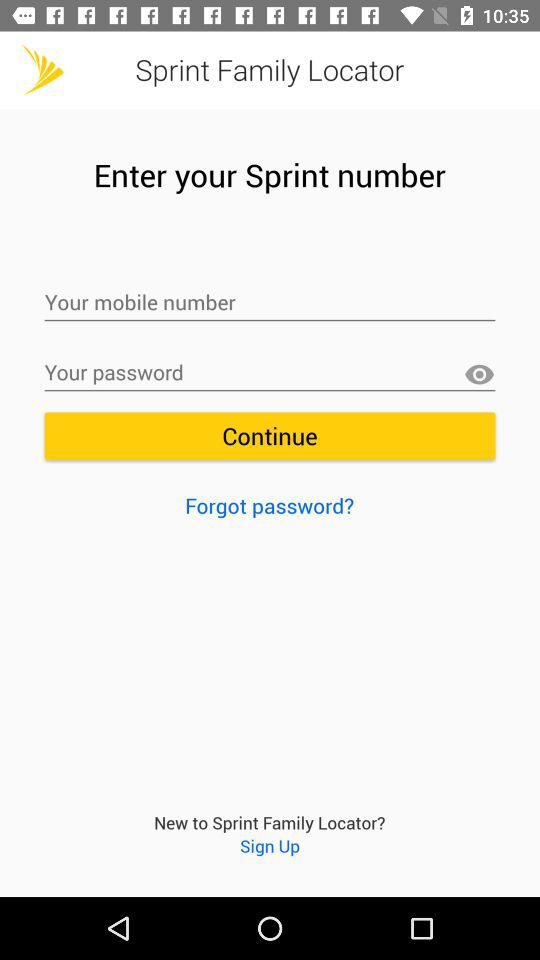What is the entered phone number?
When the provided information is insufficient, respond with <no answer>. <no answer> 